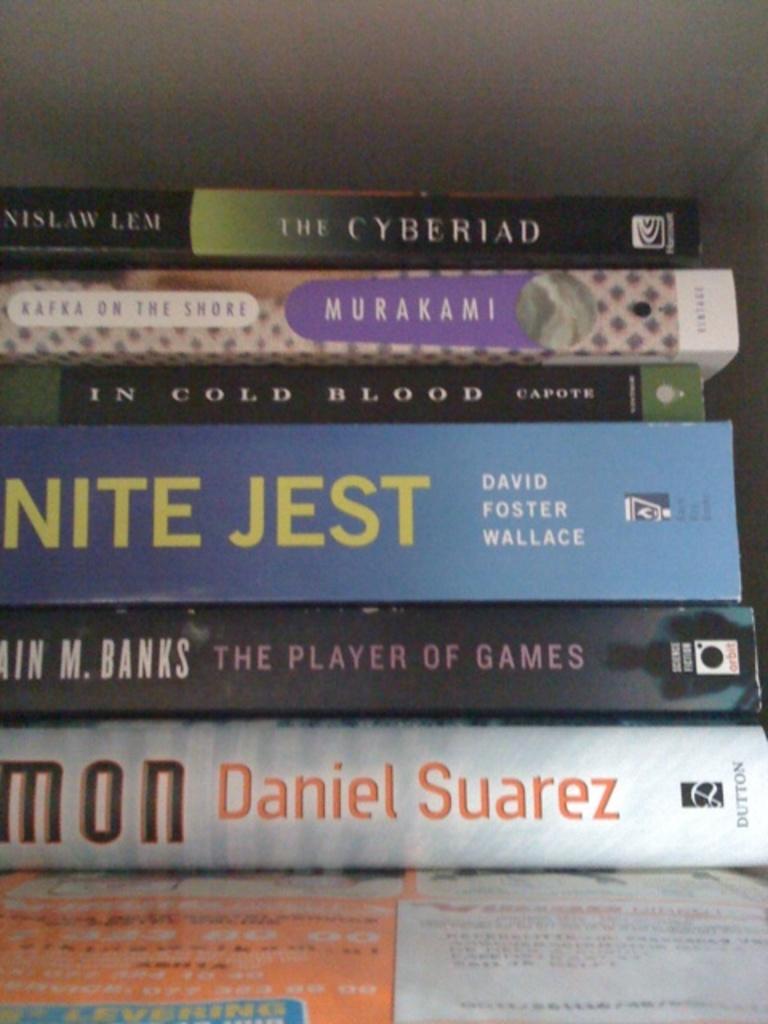What is the title of the book on the top?
Your response must be concise. The cyberiad. Is there a book by daniel suarez?
Offer a terse response. Yes. 